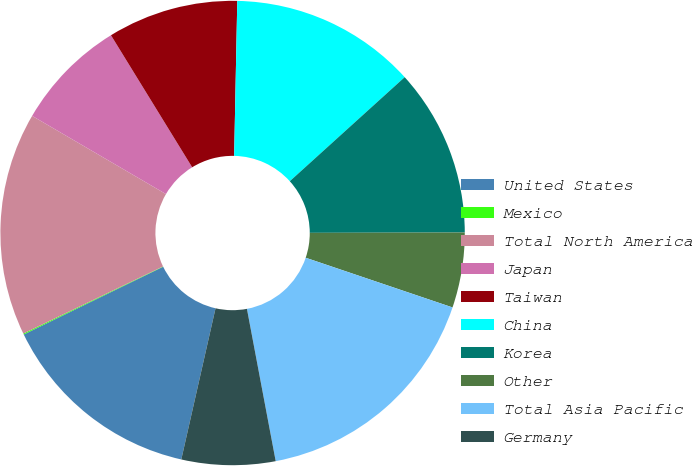<chart> <loc_0><loc_0><loc_500><loc_500><pie_chart><fcel>United States<fcel>Mexico<fcel>Total North America<fcel>Japan<fcel>Taiwan<fcel>China<fcel>Korea<fcel>Other<fcel>Total Asia Pacific<fcel>Germany<nl><fcel>14.26%<fcel>0.07%<fcel>15.55%<fcel>7.81%<fcel>9.1%<fcel>12.97%<fcel>11.68%<fcel>5.23%<fcel>16.84%<fcel>6.52%<nl></chart> 